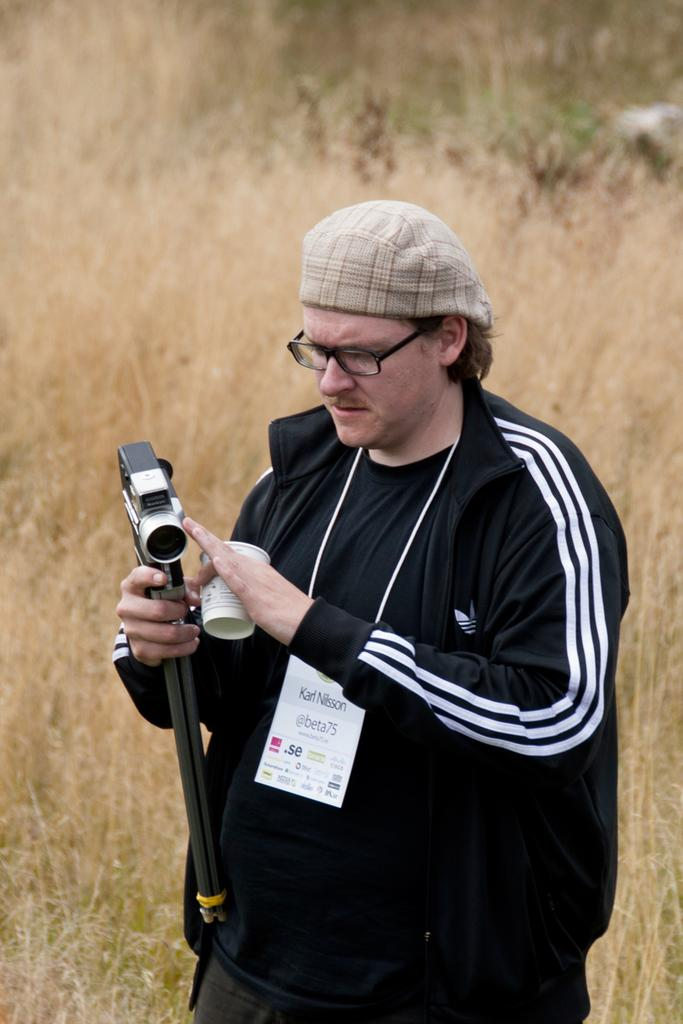Who is the main subject in the picture? There is a man in the picture. What is the man doing in the image? The man is standing. What objects is the man holding in the image? The man is holding a handycam in one hand and a cup in his other hand. How many boys are holding jewels in the image? There are no boys or jewels present in the image. What type of bears can be seen interacting with the man in the image? There are no bears present in the image; the man is holding a handycam and a cup. 